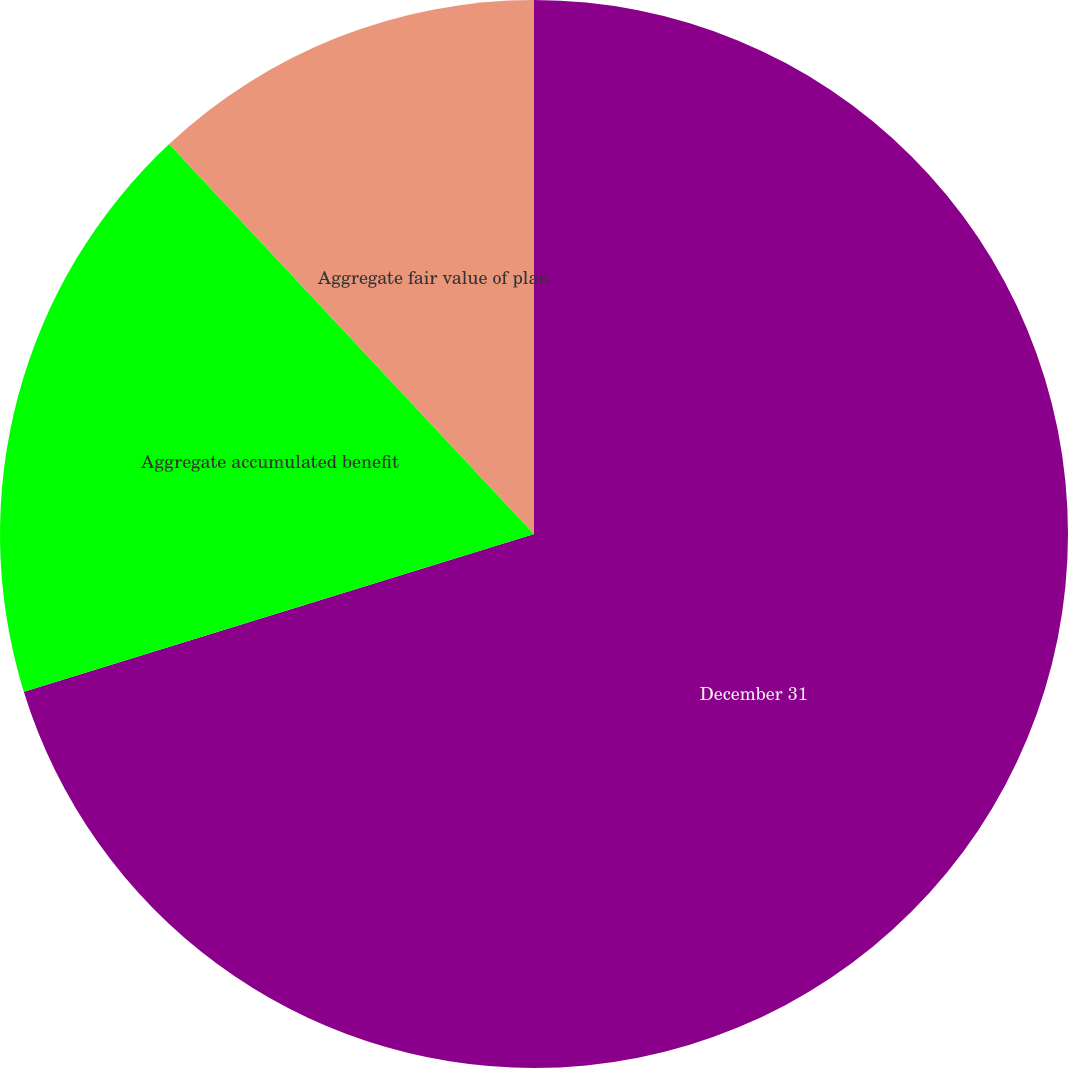Convert chart. <chart><loc_0><loc_0><loc_500><loc_500><pie_chart><fcel>December 31<fcel>Aggregate accumulated benefit<fcel>Aggregate fair value of plan<nl><fcel>70.23%<fcel>17.8%<fcel>11.97%<nl></chart> 